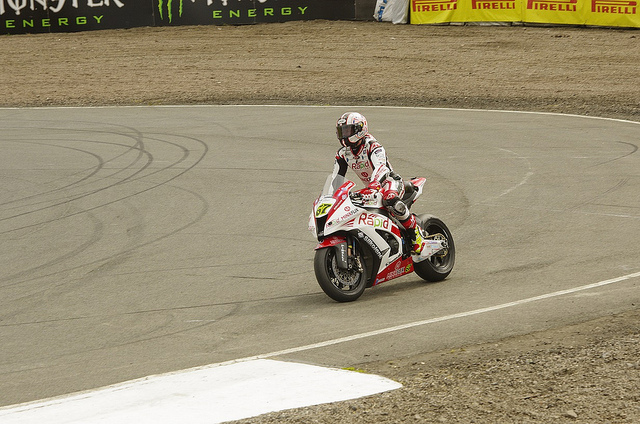<image>Who is sponsoring this event? It is unclear who is sponsoring this event. It might be Monster Energy, Red Bull, Motocross, or Pirelli. Who is sponsoring this event? It is unclear who is sponsoring this event. It could be Monster Energy, Red Bull, or possibly another sponsor. 